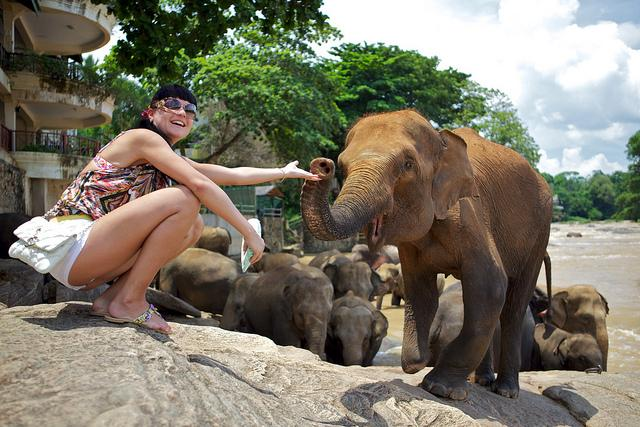What is the woman wearing?

Choices:
A) bandana
B) hat
C) jeans
D) sandals sandals 